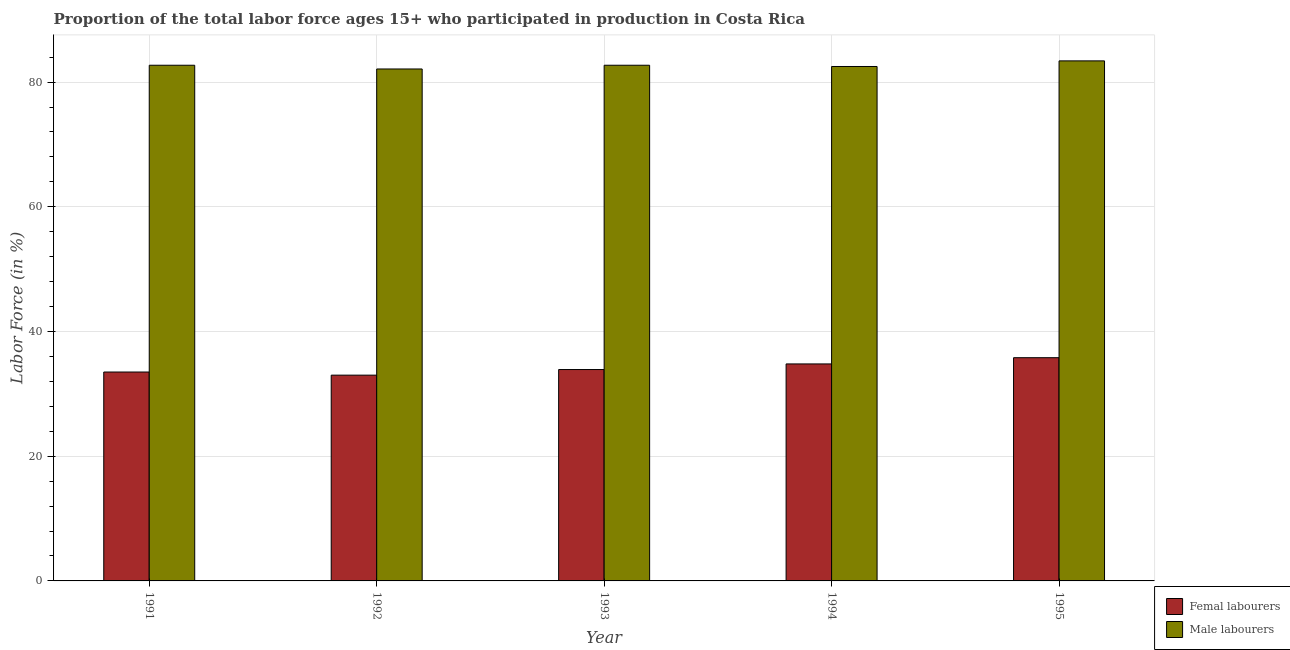Are the number of bars per tick equal to the number of legend labels?
Your answer should be very brief. Yes. Are the number of bars on each tick of the X-axis equal?
Keep it short and to the point. Yes. How many bars are there on the 2nd tick from the right?
Your answer should be compact. 2. What is the percentage of female labor force in 1993?
Provide a short and direct response. 33.9. Across all years, what is the maximum percentage of female labor force?
Ensure brevity in your answer.  35.8. Across all years, what is the minimum percentage of female labor force?
Provide a short and direct response. 33. In which year was the percentage of female labor force minimum?
Provide a short and direct response. 1992. What is the total percentage of female labor force in the graph?
Provide a succinct answer. 171. What is the difference between the percentage of male labour force in 1992 and that in 1995?
Your answer should be compact. -1.3. What is the difference between the percentage of female labor force in 1992 and the percentage of male labour force in 1995?
Provide a short and direct response. -2.8. What is the average percentage of male labour force per year?
Make the answer very short. 82.68. In how many years, is the percentage of male labour force greater than 72 %?
Provide a short and direct response. 5. What is the ratio of the percentage of female labor force in 1991 to that in 1994?
Offer a terse response. 0.96. Is the percentage of female labor force in 1991 less than that in 1995?
Offer a very short reply. Yes. Is the difference between the percentage of female labor force in 1992 and 1993 greater than the difference between the percentage of male labour force in 1992 and 1993?
Offer a terse response. No. What is the difference between the highest and the second highest percentage of female labor force?
Your response must be concise. 1. What is the difference between the highest and the lowest percentage of male labour force?
Make the answer very short. 1.3. Is the sum of the percentage of female labor force in 1991 and 1993 greater than the maximum percentage of male labour force across all years?
Provide a succinct answer. Yes. What does the 2nd bar from the left in 1995 represents?
Your answer should be very brief. Male labourers. What does the 1st bar from the right in 1993 represents?
Ensure brevity in your answer.  Male labourers. Are all the bars in the graph horizontal?
Provide a short and direct response. No. Does the graph contain any zero values?
Offer a terse response. No. Does the graph contain grids?
Provide a succinct answer. Yes. Where does the legend appear in the graph?
Give a very brief answer. Bottom right. How many legend labels are there?
Your answer should be very brief. 2. How are the legend labels stacked?
Ensure brevity in your answer.  Vertical. What is the title of the graph?
Keep it short and to the point. Proportion of the total labor force ages 15+ who participated in production in Costa Rica. What is the Labor Force (in %) in Femal labourers in 1991?
Your response must be concise. 33.5. What is the Labor Force (in %) in Male labourers in 1991?
Give a very brief answer. 82.7. What is the Labor Force (in %) of Femal labourers in 1992?
Provide a short and direct response. 33. What is the Labor Force (in %) of Male labourers in 1992?
Give a very brief answer. 82.1. What is the Labor Force (in %) of Femal labourers in 1993?
Offer a terse response. 33.9. What is the Labor Force (in %) of Male labourers in 1993?
Your answer should be compact. 82.7. What is the Labor Force (in %) of Femal labourers in 1994?
Offer a terse response. 34.8. What is the Labor Force (in %) in Male labourers in 1994?
Provide a short and direct response. 82.5. What is the Labor Force (in %) in Femal labourers in 1995?
Provide a short and direct response. 35.8. What is the Labor Force (in %) in Male labourers in 1995?
Offer a very short reply. 83.4. Across all years, what is the maximum Labor Force (in %) of Femal labourers?
Offer a very short reply. 35.8. Across all years, what is the maximum Labor Force (in %) of Male labourers?
Keep it short and to the point. 83.4. Across all years, what is the minimum Labor Force (in %) in Femal labourers?
Provide a short and direct response. 33. Across all years, what is the minimum Labor Force (in %) in Male labourers?
Make the answer very short. 82.1. What is the total Labor Force (in %) in Femal labourers in the graph?
Make the answer very short. 171. What is the total Labor Force (in %) in Male labourers in the graph?
Offer a very short reply. 413.4. What is the difference between the Labor Force (in %) in Male labourers in 1991 and that in 1992?
Ensure brevity in your answer.  0.6. What is the difference between the Labor Force (in %) of Femal labourers in 1991 and that in 1993?
Give a very brief answer. -0.4. What is the difference between the Labor Force (in %) in Male labourers in 1991 and that in 1994?
Provide a short and direct response. 0.2. What is the difference between the Labor Force (in %) in Male labourers in 1992 and that in 1993?
Provide a short and direct response. -0.6. What is the difference between the Labor Force (in %) of Male labourers in 1992 and that in 1994?
Your answer should be very brief. -0.4. What is the difference between the Labor Force (in %) in Male labourers in 1993 and that in 1994?
Your answer should be very brief. 0.2. What is the difference between the Labor Force (in %) in Male labourers in 1993 and that in 1995?
Make the answer very short. -0.7. What is the difference between the Labor Force (in %) of Femal labourers in 1994 and that in 1995?
Provide a short and direct response. -1. What is the difference between the Labor Force (in %) of Femal labourers in 1991 and the Labor Force (in %) of Male labourers in 1992?
Your answer should be compact. -48.6. What is the difference between the Labor Force (in %) in Femal labourers in 1991 and the Labor Force (in %) in Male labourers in 1993?
Offer a very short reply. -49.2. What is the difference between the Labor Force (in %) in Femal labourers in 1991 and the Labor Force (in %) in Male labourers in 1994?
Provide a succinct answer. -49. What is the difference between the Labor Force (in %) in Femal labourers in 1991 and the Labor Force (in %) in Male labourers in 1995?
Your answer should be compact. -49.9. What is the difference between the Labor Force (in %) in Femal labourers in 1992 and the Labor Force (in %) in Male labourers in 1993?
Keep it short and to the point. -49.7. What is the difference between the Labor Force (in %) of Femal labourers in 1992 and the Labor Force (in %) of Male labourers in 1994?
Ensure brevity in your answer.  -49.5. What is the difference between the Labor Force (in %) of Femal labourers in 1992 and the Labor Force (in %) of Male labourers in 1995?
Your response must be concise. -50.4. What is the difference between the Labor Force (in %) of Femal labourers in 1993 and the Labor Force (in %) of Male labourers in 1994?
Give a very brief answer. -48.6. What is the difference between the Labor Force (in %) in Femal labourers in 1993 and the Labor Force (in %) in Male labourers in 1995?
Give a very brief answer. -49.5. What is the difference between the Labor Force (in %) of Femal labourers in 1994 and the Labor Force (in %) of Male labourers in 1995?
Provide a succinct answer. -48.6. What is the average Labor Force (in %) in Femal labourers per year?
Ensure brevity in your answer.  34.2. What is the average Labor Force (in %) of Male labourers per year?
Your response must be concise. 82.68. In the year 1991, what is the difference between the Labor Force (in %) of Femal labourers and Labor Force (in %) of Male labourers?
Give a very brief answer. -49.2. In the year 1992, what is the difference between the Labor Force (in %) in Femal labourers and Labor Force (in %) in Male labourers?
Your answer should be compact. -49.1. In the year 1993, what is the difference between the Labor Force (in %) of Femal labourers and Labor Force (in %) of Male labourers?
Make the answer very short. -48.8. In the year 1994, what is the difference between the Labor Force (in %) of Femal labourers and Labor Force (in %) of Male labourers?
Your response must be concise. -47.7. In the year 1995, what is the difference between the Labor Force (in %) of Femal labourers and Labor Force (in %) of Male labourers?
Make the answer very short. -47.6. What is the ratio of the Labor Force (in %) in Femal labourers in 1991 to that in 1992?
Keep it short and to the point. 1.02. What is the ratio of the Labor Force (in %) of Male labourers in 1991 to that in 1992?
Your response must be concise. 1.01. What is the ratio of the Labor Force (in %) of Femal labourers in 1991 to that in 1994?
Your response must be concise. 0.96. What is the ratio of the Labor Force (in %) in Male labourers in 1991 to that in 1994?
Provide a short and direct response. 1. What is the ratio of the Labor Force (in %) of Femal labourers in 1991 to that in 1995?
Offer a very short reply. 0.94. What is the ratio of the Labor Force (in %) of Femal labourers in 1992 to that in 1993?
Keep it short and to the point. 0.97. What is the ratio of the Labor Force (in %) in Male labourers in 1992 to that in 1993?
Keep it short and to the point. 0.99. What is the ratio of the Labor Force (in %) in Femal labourers in 1992 to that in 1994?
Offer a very short reply. 0.95. What is the ratio of the Labor Force (in %) of Male labourers in 1992 to that in 1994?
Keep it short and to the point. 1. What is the ratio of the Labor Force (in %) of Femal labourers in 1992 to that in 1995?
Provide a succinct answer. 0.92. What is the ratio of the Labor Force (in %) of Male labourers in 1992 to that in 1995?
Your answer should be very brief. 0.98. What is the ratio of the Labor Force (in %) of Femal labourers in 1993 to that in 1994?
Make the answer very short. 0.97. What is the ratio of the Labor Force (in %) in Male labourers in 1993 to that in 1994?
Provide a short and direct response. 1. What is the ratio of the Labor Force (in %) of Femal labourers in 1993 to that in 1995?
Provide a short and direct response. 0.95. What is the ratio of the Labor Force (in %) of Male labourers in 1993 to that in 1995?
Make the answer very short. 0.99. What is the ratio of the Labor Force (in %) of Femal labourers in 1994 to that in 1995?
Provide a short and direct response. 0.97. What is the ratio of the Labor Force (in %) in Male labourers in 1994 to that in 1995?
Your response must be concise. 0.99. What is the difference between the highest and the second highest Labor Force (in %) in Male labourers?
Offer a terse response. 0.7. What is the difference between the highest and the lowest Labor Force (in %) of Male labourers?
Provide a short and direct response. 1.3. 